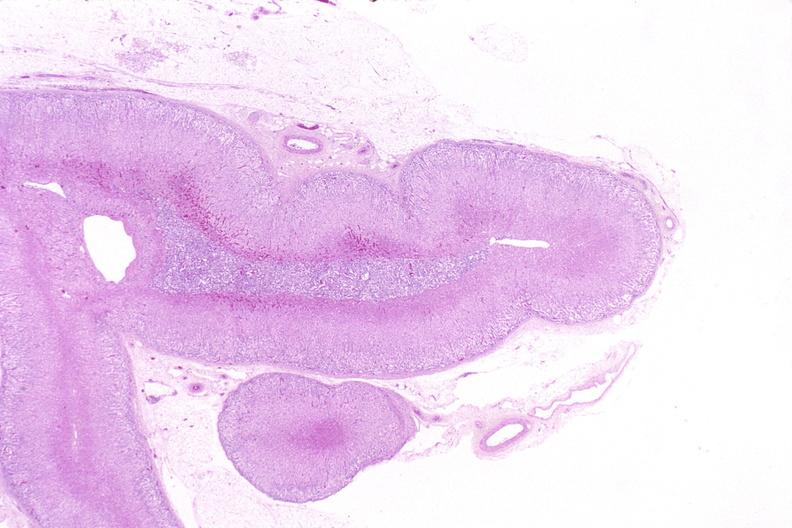where is this part in the figure?
Answer the question using a single word or phrase. Endocrine system 